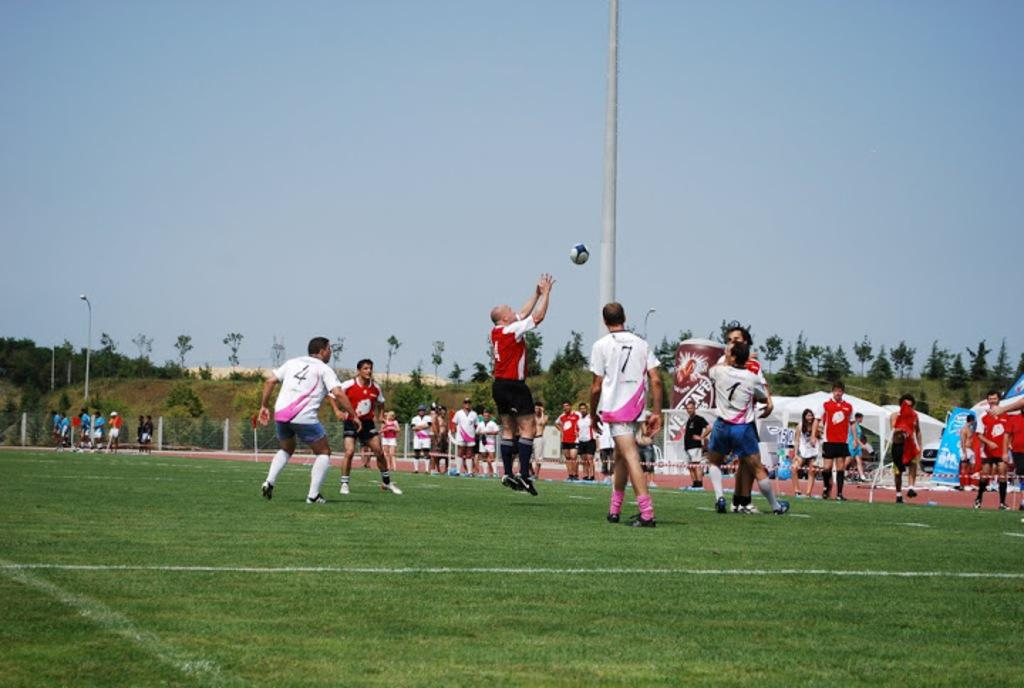<image>
Share a concise interpretation of the image provided. a player has the number 7 on their jersey 